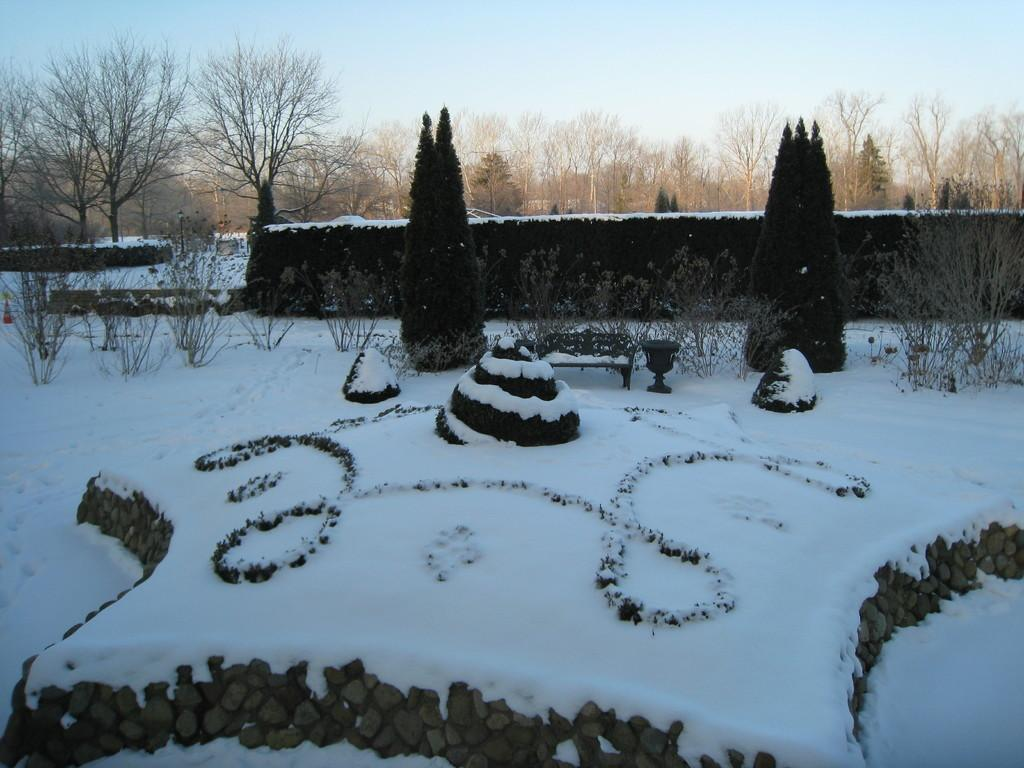What type of natural elements can be seen in the image? There are stones, snow, and trees in the image. What man-made objects are present in the image? There is a bench and a wall in the image. What is the primary object in the image? There is an object in the image, but its specific nature is not mentioned in the facts. What can be seen in the background of the image? The sky is visible in the background of the image. What type of mint can be seen growing near the bench in the image? There is no mention of mint or any plant life in the image, so it cannot be determined if mint is present. 